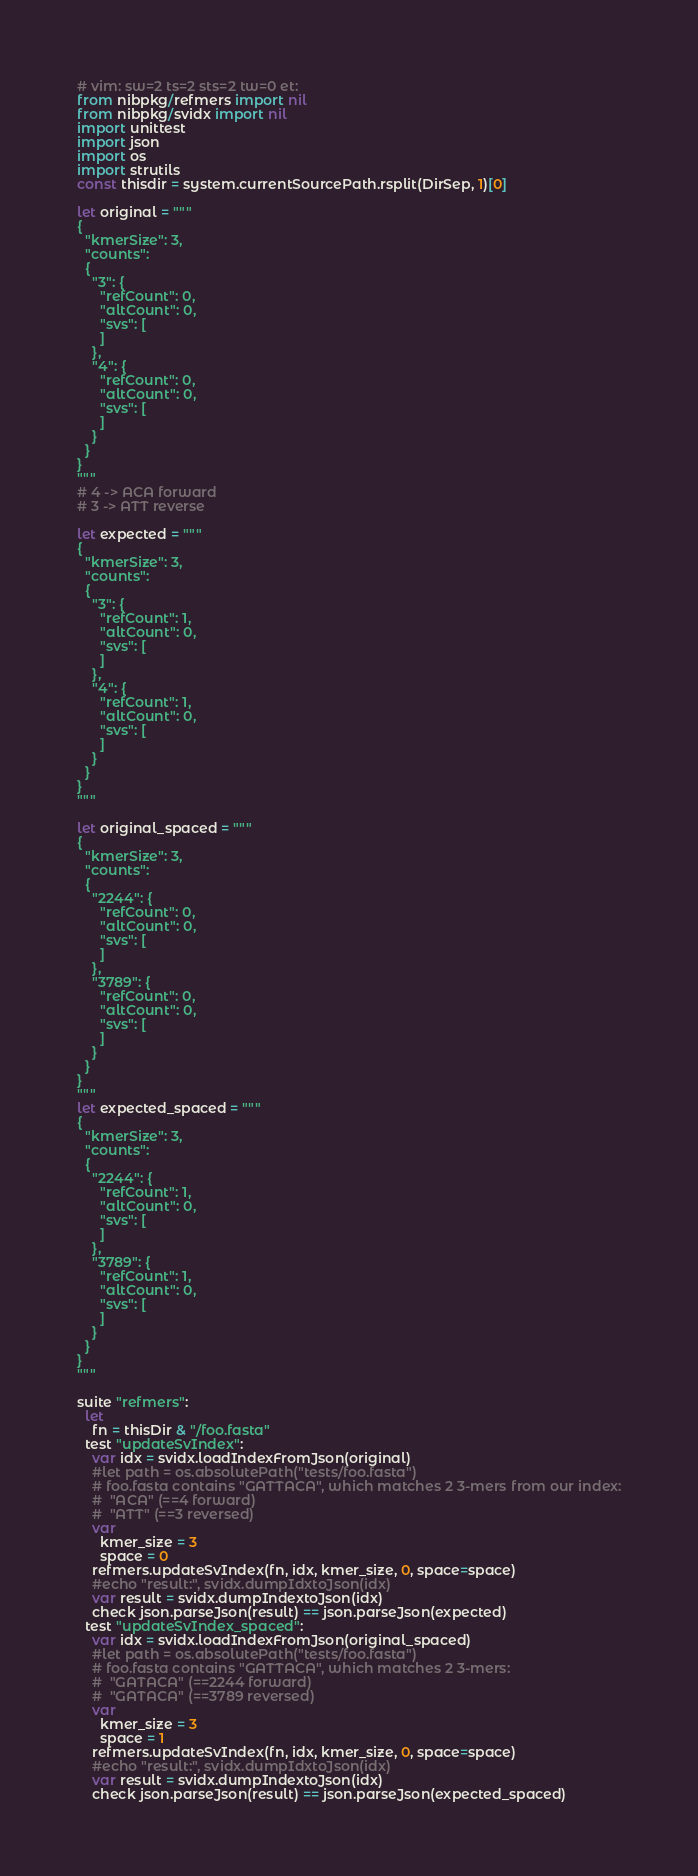Convert code to text. <code><loc_0><loc_0><loc_500><loc_500><_Nim_># vim: sw=2 ts=2 sts=2 tw=0 et:
from nibpkg/refmers import nil
from nibpkg/svidx import nil
import unittest
import json
import os
import strutils
const thisdir = system.currentSourcePath.rsplit(DirSep, 1)[0]

let original = """
{
  "kmerSize": 3,
  "counts":
  {
    "3": {
      "refCount": 0,
      "altCount": 0,
      "svs": [
      ]
    },
    "4": {
      "refCount": 0,
      "altCount": 0,
      "svs": [
      ]
    }
  }
}
"""
# 4 -> ACA forward
# 3 -> ATT reverse

let expected = """
{
  "kmerSize": 3,
  "counts":
  {
    "3": {
      "refCount": 1,
      "altCount": 0,
      "svs": [
      ]
    },
    "4": {
      "refCount": 1,
      "altCount": 0,
      "svs": [
      ]
    }
  }
}
"""

let original_spaced = """
{
  "kmerSize": 3,
  "counts":
  {
    "2244": {
      "refCount": 0,
      "altCount": 0,
      "svs": [
      ]
    },
    "3789": {
      "refCount": 0,
      "altCount": 0,
      "svs": [
      ]
    }
  }
}
"""
let expected_spaced = """
{
  "kmerSize": 3,
  "counts":
  {
    "2244": {
      "refCount": 1,
      "altCount": 0,
      "svs": [
      ]
    },
    "3789": {
      "refCount": 1,
      "altCount": 0,
      "svs": [
      ]
    }
  }
}
"""

suite "refmers":
  let
    fn = thisDir & "/foo.fasta"
  test "updateSvIndex":
    var idx = svidx.loadIndexFromJson(original)
    #let path = os.absolutePath("tests/foo.fasta")
    # foo.fasta contains "GATTACA", which matches 2 3-mers from our index:
    #  "ACA" (==4 forward)
    #  "ATT" (==3 reversed)
    var
      kmer_size = 3
      space = 0
    refmers.updateSvIndex(fn, idx, kmer_size, 0, space=space)
    #echo "result:", svidx.dumpIdxtoJson(idx)
    var result = svidx.dumpIndextoJson(idx)
    check json.parseJson(result) == json.parseJson(expected)
  test "updateSvIndex_spaced":
    var idx = svidx.loadIndexFromJson(original_spaced)
    #let path = os.absolutePath("tests/foo.fasta")
    # foo.fasta contains "GATTACA", which matches 2 3-mers:
    #  "GATACA" (==2244 forward)
    #  "GATACA" (==3789 reversed)
    var
      kmer_size = 3
      space = 1
    refmers.updateSvIndex(fn, idx, kmer_size, 0, space=space)
    #echo "result:", svidx.dumpIdxtoJson(idx)
    var result = svidx.dumpIndextoJson(idx)
    check json.parseJson(result) == json.parseJson(expected_spaced)
</code> 